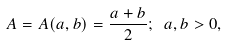Convert formula to latex. <formula><loc_0><loc_0><loc_500><loc_500>A = A ( a , b ) = \frac { a + b } { 2 } ; \text { } a , b > 0 ,</formula> 